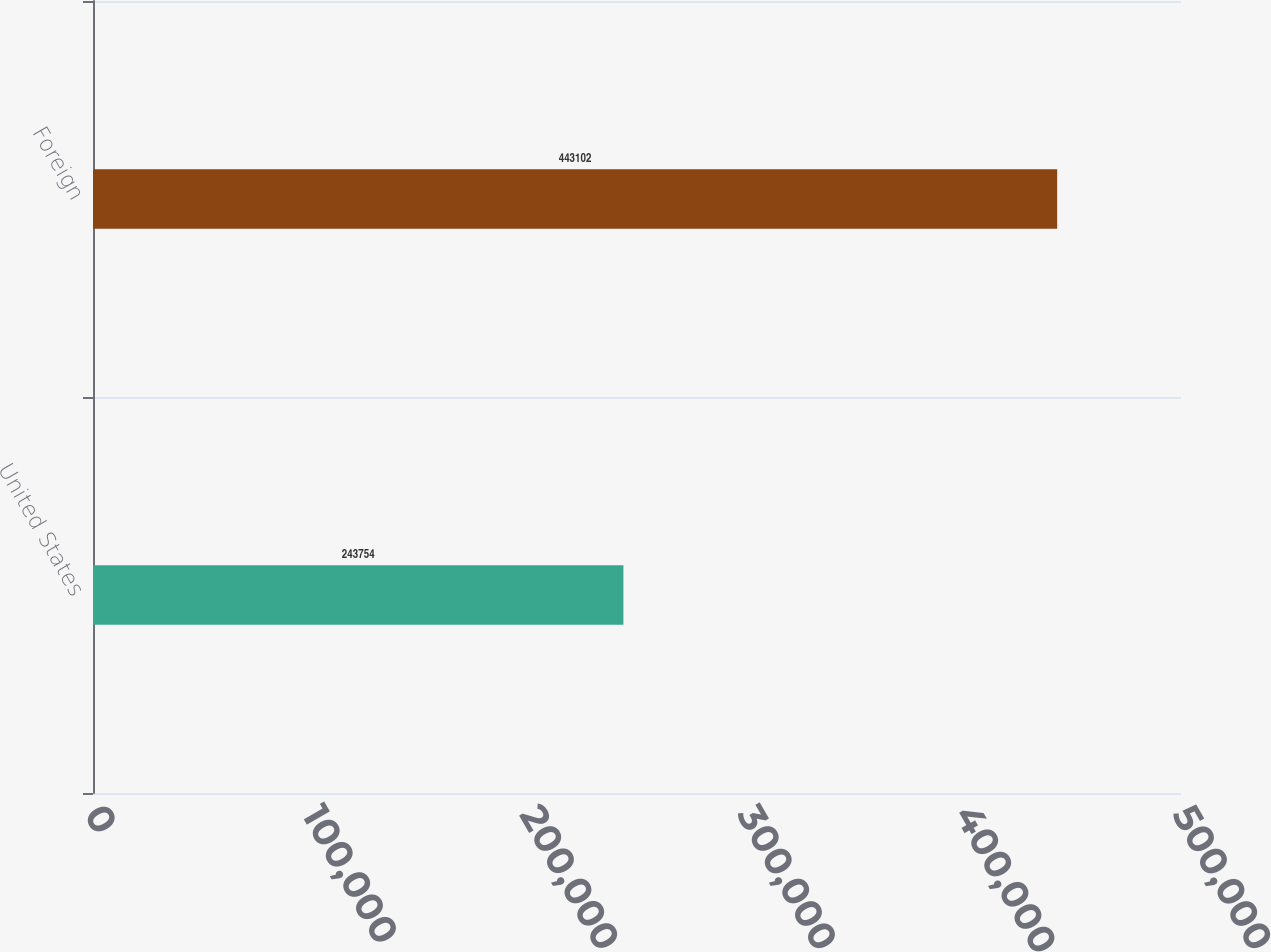Convert chart. <chart><loc_0><loc_0><loc_500><loc_500><bar_chart><fcel>United States<fcel>Foreign<nl><fcel>243754<fcel>443102<nl></chart> 